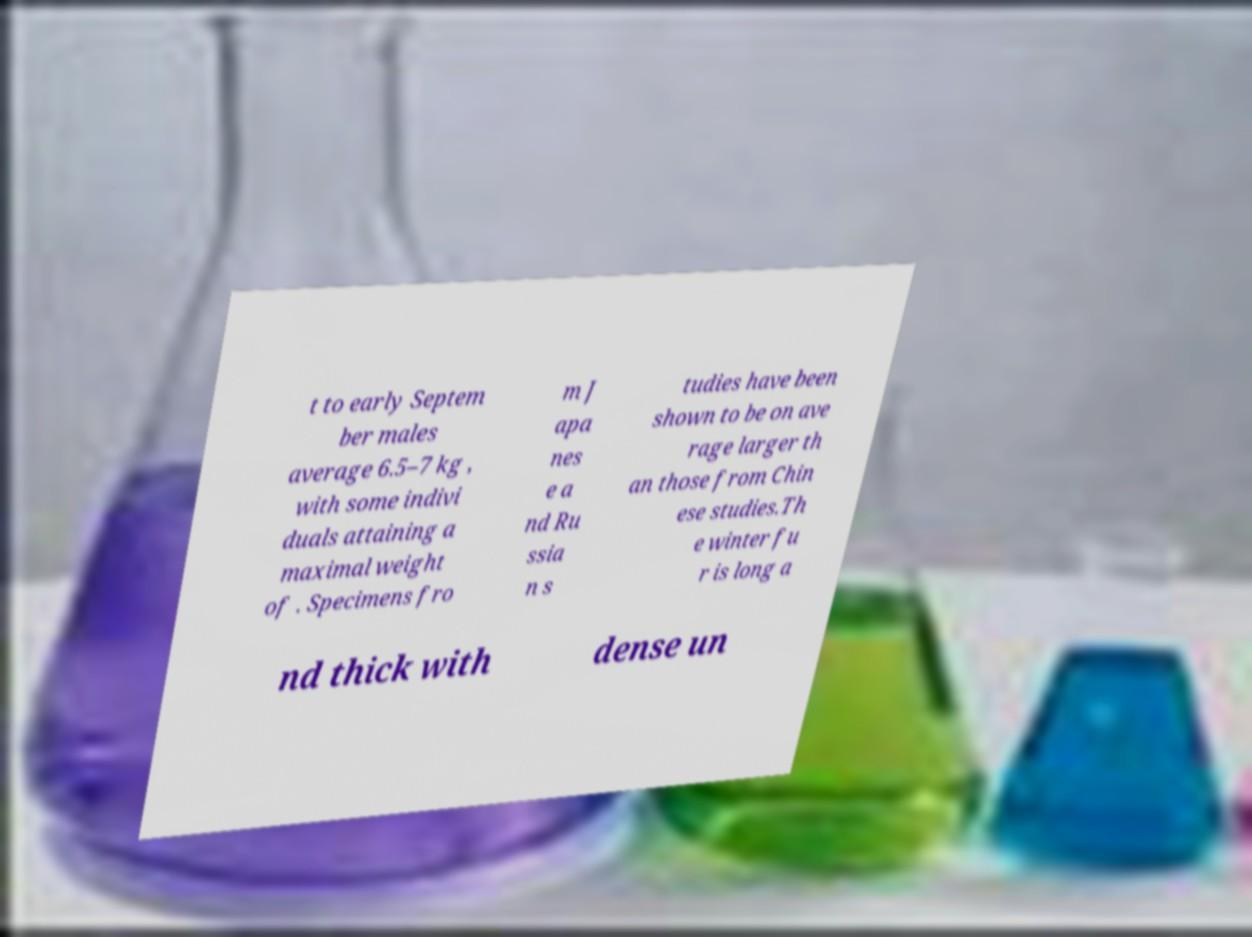There's text embedded in this image that I need extracted. Can you transcribe it verbatim? t to early Septem ber males average 6.5–7 kg , with some indivi duals attaining a maximal weight of . Specimens fro m J apa nes e a nd Ru ssia n s tudies have been shown to be on ave rage larger th an those from Chin ese studies.Th e winter fu r is long a nd thick with dense un 